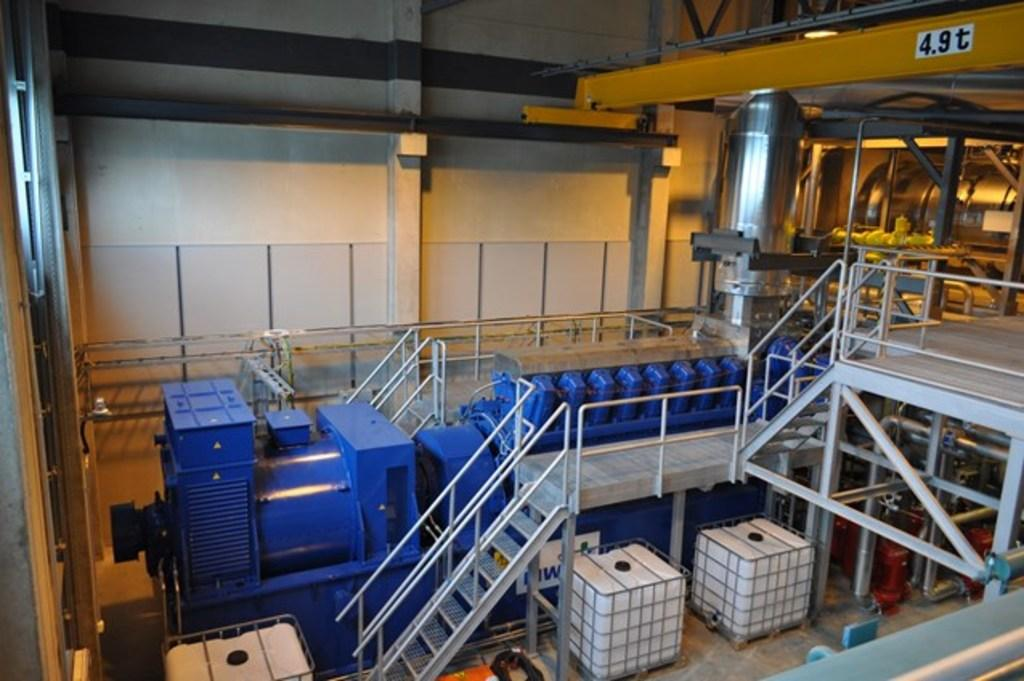What type of location is depicted in the image? The image is taken in a factory. What objects are used for transporting items in the factory? There are carriers in the image. Can you describe a feature that allows for vertical movement in the factory? There is a staircase in the image. What safety feature is present in the image? There is a railing in the image. What type of storage units are visible in the image? There are containers in the image. What provides illumination in the factory? There are lights in the image. What type of infrastructure is present for transporting fluids or gases? There are pipes in the image. What type of barrier separates different areas in the factory? There is a wall in the image. How does the tin affect the slope in the image? There is no tin or slope present in the image. 